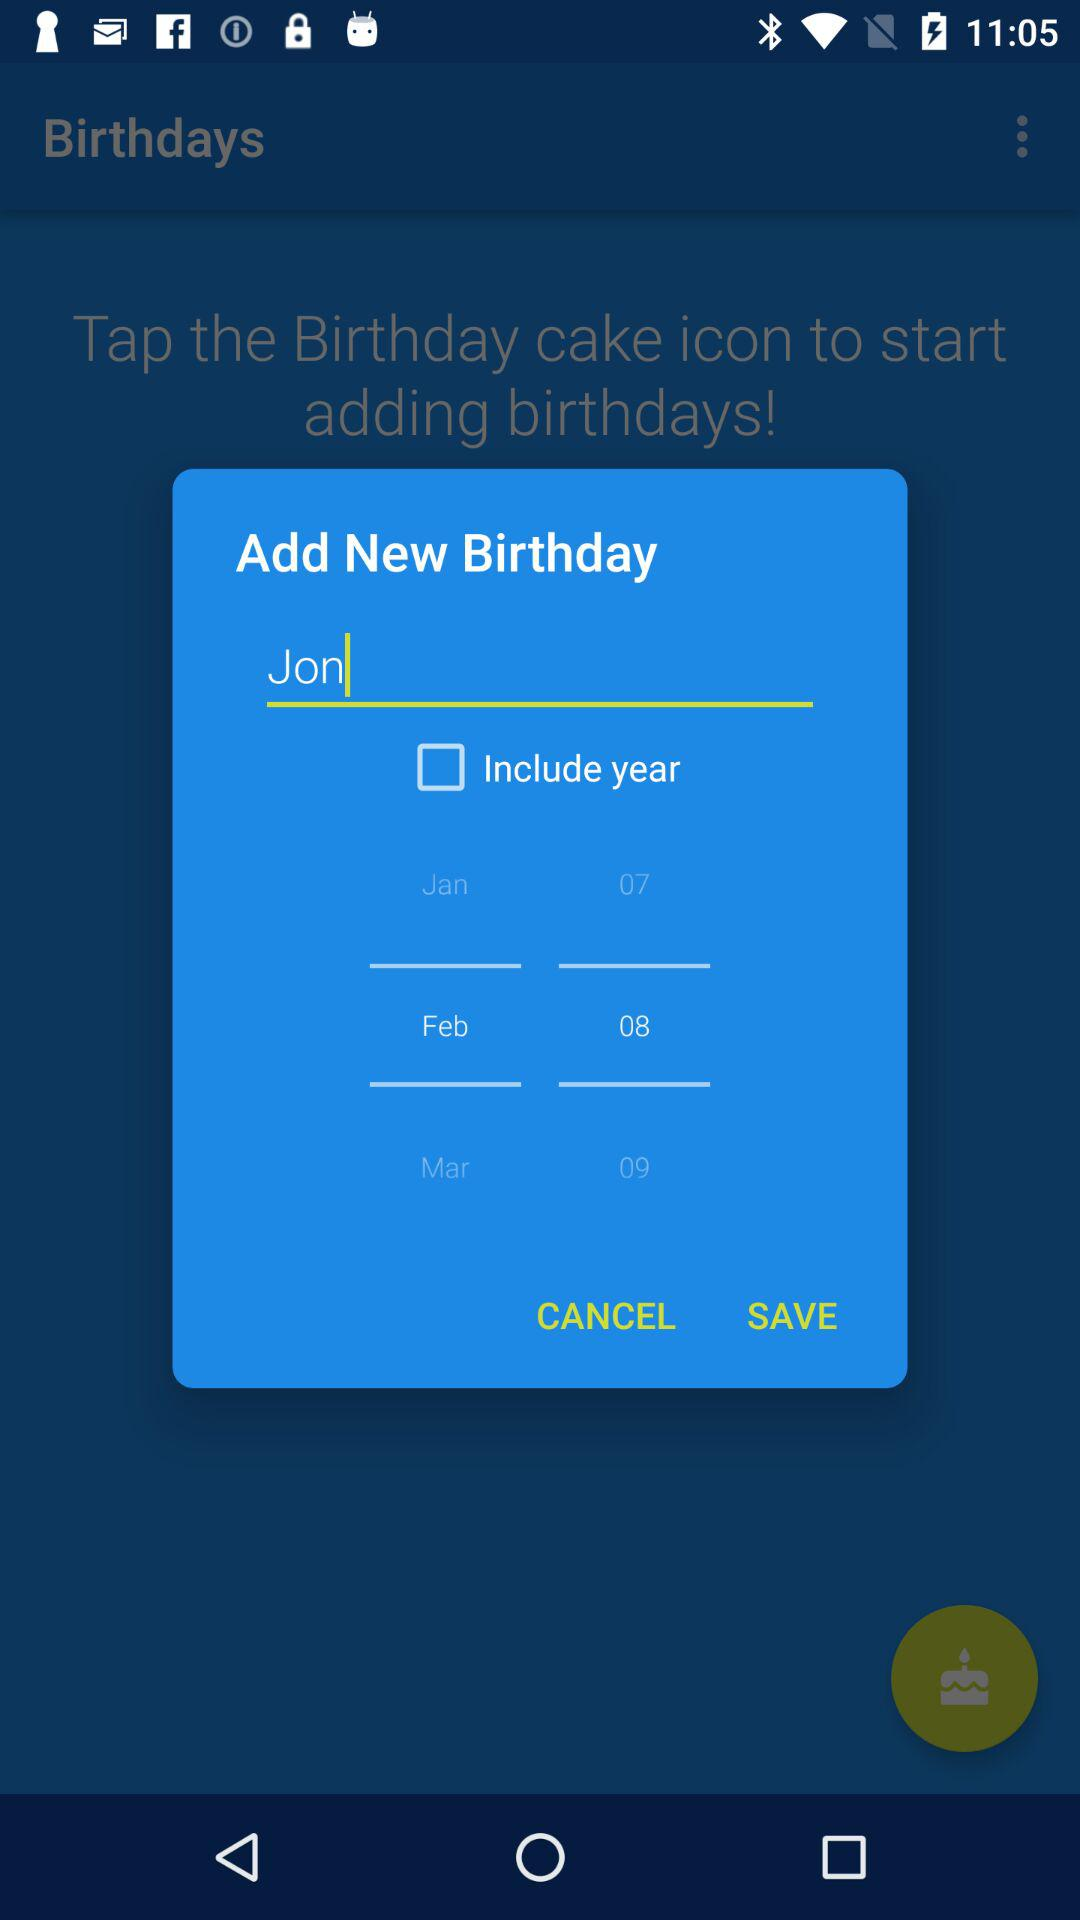How many birthdays can we add?
When the provided information is insufficient, respond with <no answer>. <no answer> 